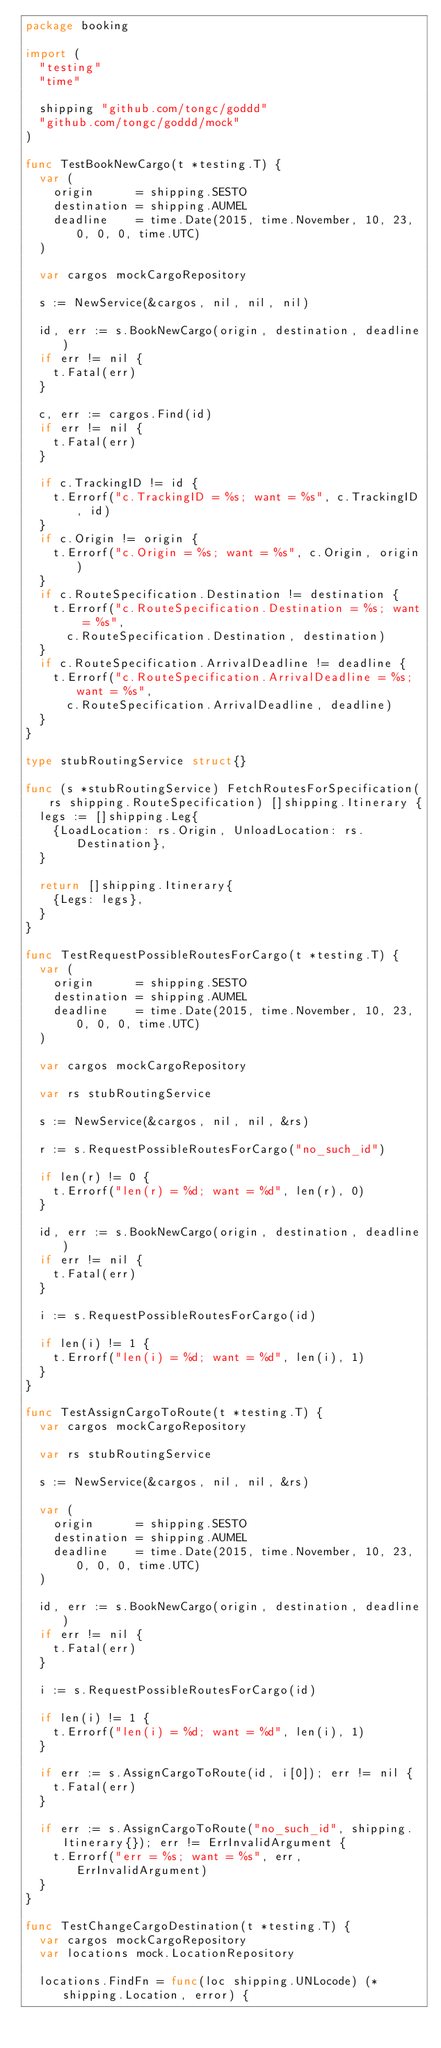<code> <loc_0><loc_0><loc_500><loc_500><_Go_>package booking

import (
	"testing"
	"time"

	shipping "github.com/tongc/goddd"
	"github.com/tongc/goddd/mock"
)

func TestBookNewCargo(t *testing.T) {
	var (
		origin      = shipping.SESTO
		destination = shipping.AUMEL
		deadline    = time.Date(2015, time.November, 10, 23, 0, 0, 0, time.UTC)
	)

	var cargos mockCargoRepository

	s := NewService(&cargos, nil, nil, nil)

	id, err := s.BookNewCargo(origin, destination, deadline)
	if err != nil {
		t.Fatal(err)
	}

	c, err := cargos.Find(id)
	if err != nil {
		t.Fatal(err)
	}

	if c.TrackingID != id {
		t.Errorf("c.TrackingID = %s; want = %s", c.TrackingID, id)
	}
	if c.Origin != origin {
		t.Errorf("c.Origin = %s; want = %s", c.Origin, origin)
	}
	if c.RouteSpecification.Destination != destination {
		t.Errorf("c.RouteSpecification.Destination = %s; want = %s",
			c.RouteSpecification.Destination, destination)
	}
	if c.RouteSpecification.ArrivalDeadline != deadline {
		t.Errorf("c.RouteSpecification.ArrivalDeadline = %s; want = %s",
			c.RouteSpecification.ArrivalDeadline, deadline)
	}
}

type stubRoutingService struct{}

func (s *stubRoutingService) FetchRoutesForSpecification(rs shipping.RouteSpecification) []shipping.Itinerary {
	legs := []shipping.Leg{
		{LoadLocation: rs.Origin, UnloadLocation: rs.Destination},
	}

	return []shipping.Itinerary{
		{Legs: legs},
	}
}

func TestRequestPossibleRoutesForCargo(t *testing.T) {
	var (
		origin      = shipping.SESTO
		destination = shipping.AUMEL
		deadline    = time.Date(2015, time.November, 10, 23, 0, 0, 0, time.UTC)
	)

	var cargos mockCargoRepository

	var rs stubRoutingService

	s := NewService(&cargos, nil, nil, &rs)

	r := s.RequestPossibleRoutesForCargo("no_such_id")

	if len(r) != 0 {
		t.Errorf("len(r) = %d; want = %d", len(r), 0)
	}

	id, err := s.BookNewCargo(origin, destination, deadline)
	if err != nil {
		t.Fatal(err)
	}

	i := s.RequestPossibleRoutesForCargo(id)

	if len(i) != 1 {
		t.Errorf("len(i) = %d; want = %d", len(i), 1)
	}
}

func TestAssignCargoToRoute(t *testing.T) {
	var cargos mockCargoRepository

	var rs stubRoutingService

	s := NewService(&cargos, nil, nil, &rs)

	var (
		origin      = shipping.SESTO
		destination = shipping.AUMEL
		deadline    = time.Date(2015, time.November, 10, 23, 0, 0, 0, time.UTC)
	)

	id, err := s.BookNewCargo(origin, destination, deadline)
	if err != nil {
		t.Fatal(err)
	}

	i := s.RequestPossibleRoutesForCargo(id)

	if len(i) != 1 {
		t.Errorf("len(i) = %d; want = %d", len(i), 1)
	}

	if err := s.AssignCargoToRoute(id, i[0]); err != nil {
		t.Fatal(err)
	}

	if err := s.AssignCargoToRoute("no_such_id", shipping.Itinerary{}); err != ErrInvalidArgument {
		t.Errorf("err = %s; want = %s", err, ErrInvalidArgument)
	}
}

func TestChangeCargoDestination(t *testing.T) {
	var cargos mockCargoRepository
	var locations mock.LocationRepository

	locations.FindFn = func(loc shipping.UNLocode) (*shipping.Location, error) {</code> 